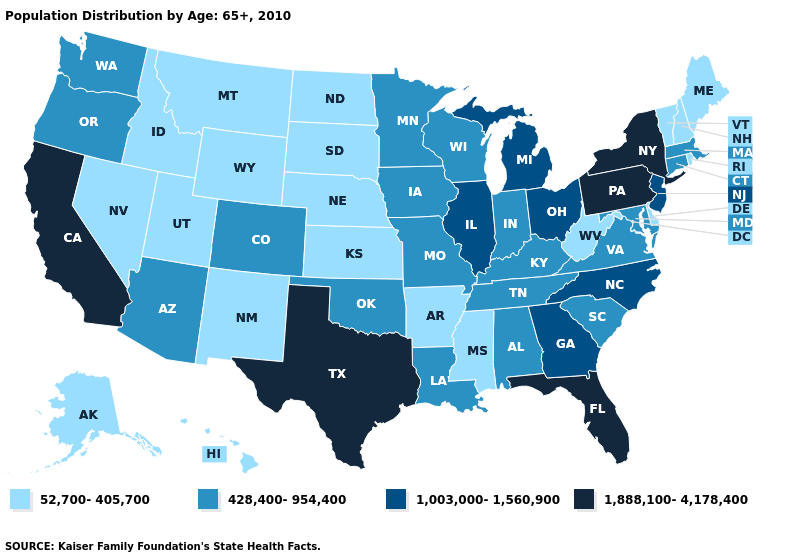What is the lowest value in the USA?
Answer briefly. 52,700-405,700. Does North Dakota have the lowest value in the MidWest?
Short answer required. Yes. What is the value of Arkansas?
Short answer required. 52,700-405,700. What is the value of Idaho?
Write a very short answer. 52,700-405,700. Name the states that have a value in the range 1,888,100-4,178,400?
Short answer required. California, Florida, New York, Pennsylvania, Texas. Among the states that border Minnesota , does Iowa have the lowest value?
Concise answer only. No. What is the value of Virginia?
Answer briefly. 428,400-954,400. What is the lowest value in the USA?
Be succinct. 52,700-405,700. Does Michigan have the lowest value in the MidWest?
Concise answer only. No. Name the states that have a value in the range 1,888,100-4,178,400?
Keep it brief. California, Florida, New York, Pennsylvania, Texas. Among the states that border Mississippi , which have the highest value?
Short answer required. Alabama, Louisiana, Tennessee. What is the highest value in the USA?
Write a very short answer. 1,888,100-4,178,400. Which states have the highest value in the USA?
Answer briefly. California, Florida, New York, Pennsylvania, Texas. What is the value of Massachusetts?
Quick response, please. 428,400-954,400. Which states have the highest value in the USA?
Quick response, please. California, Florida, New York, Pennsylvania, Texas. 